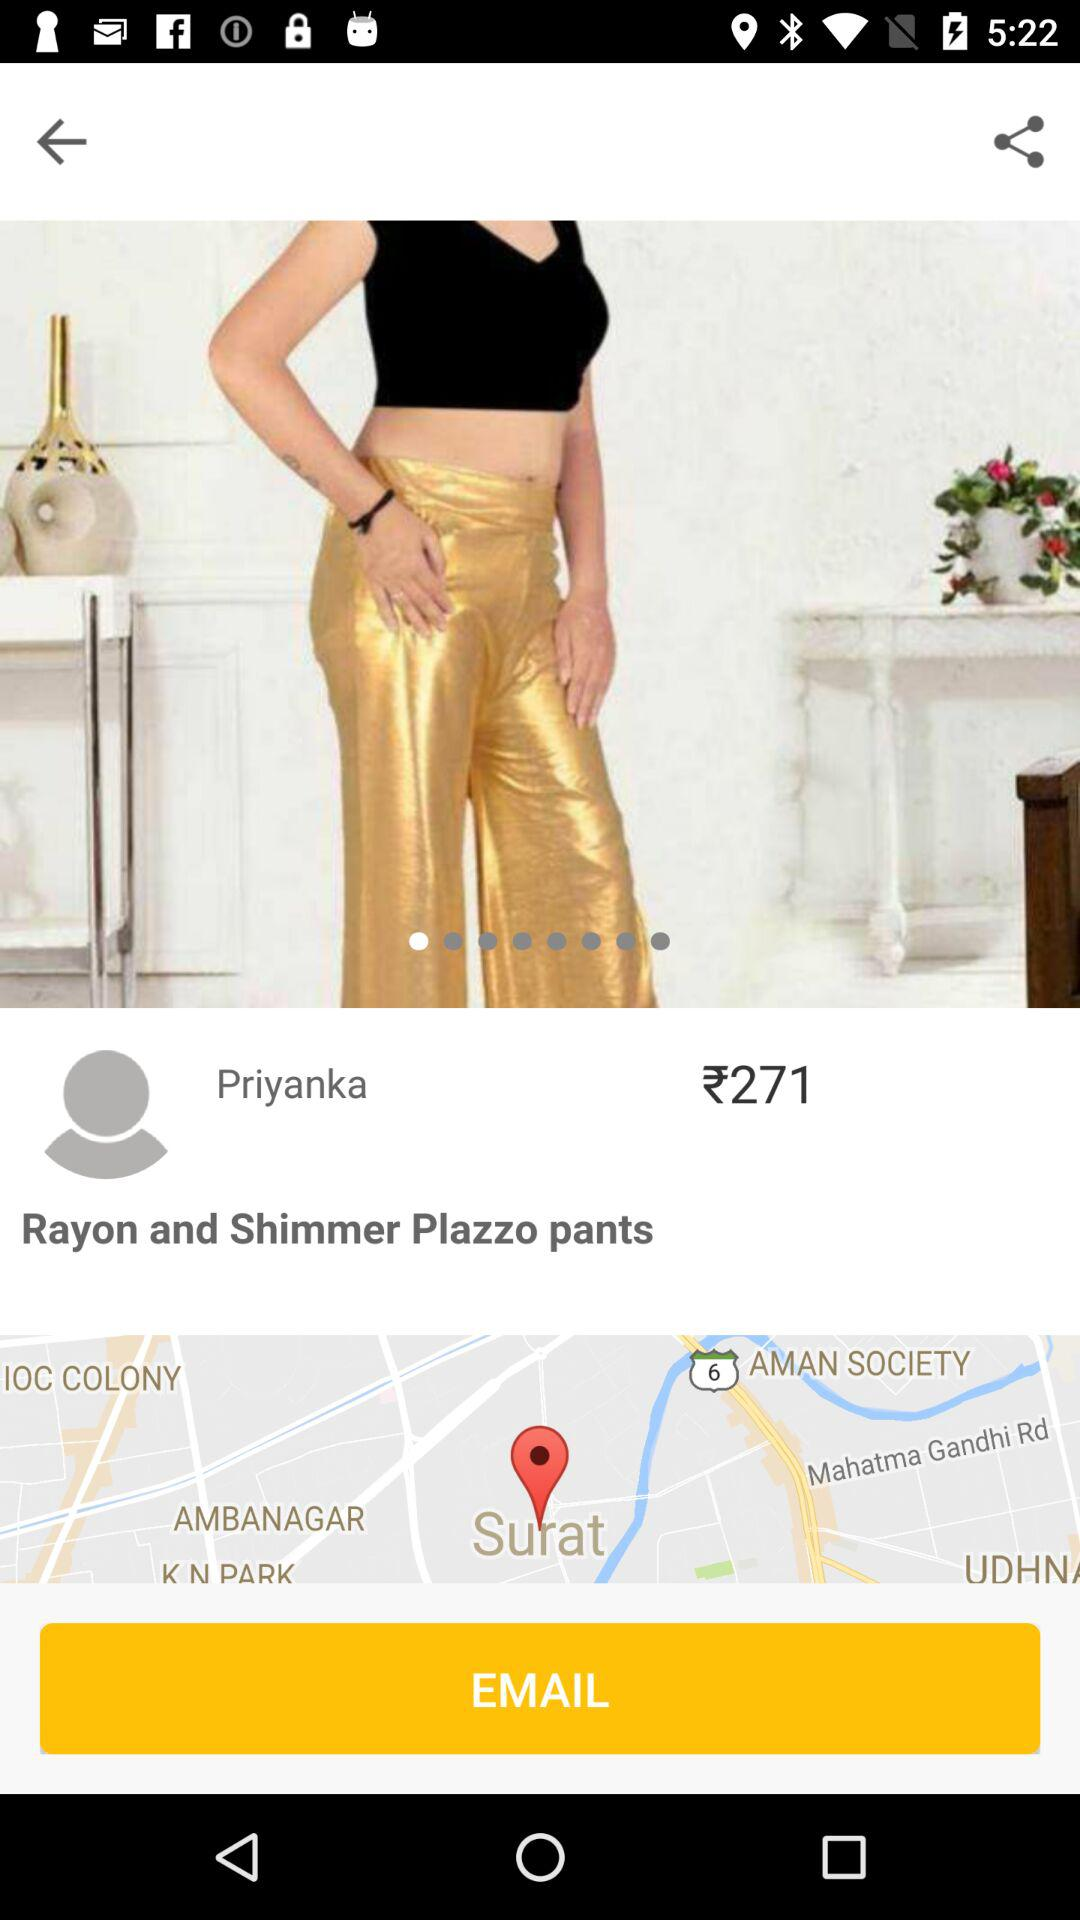What is the profile name? The profile name is Priyanka. 